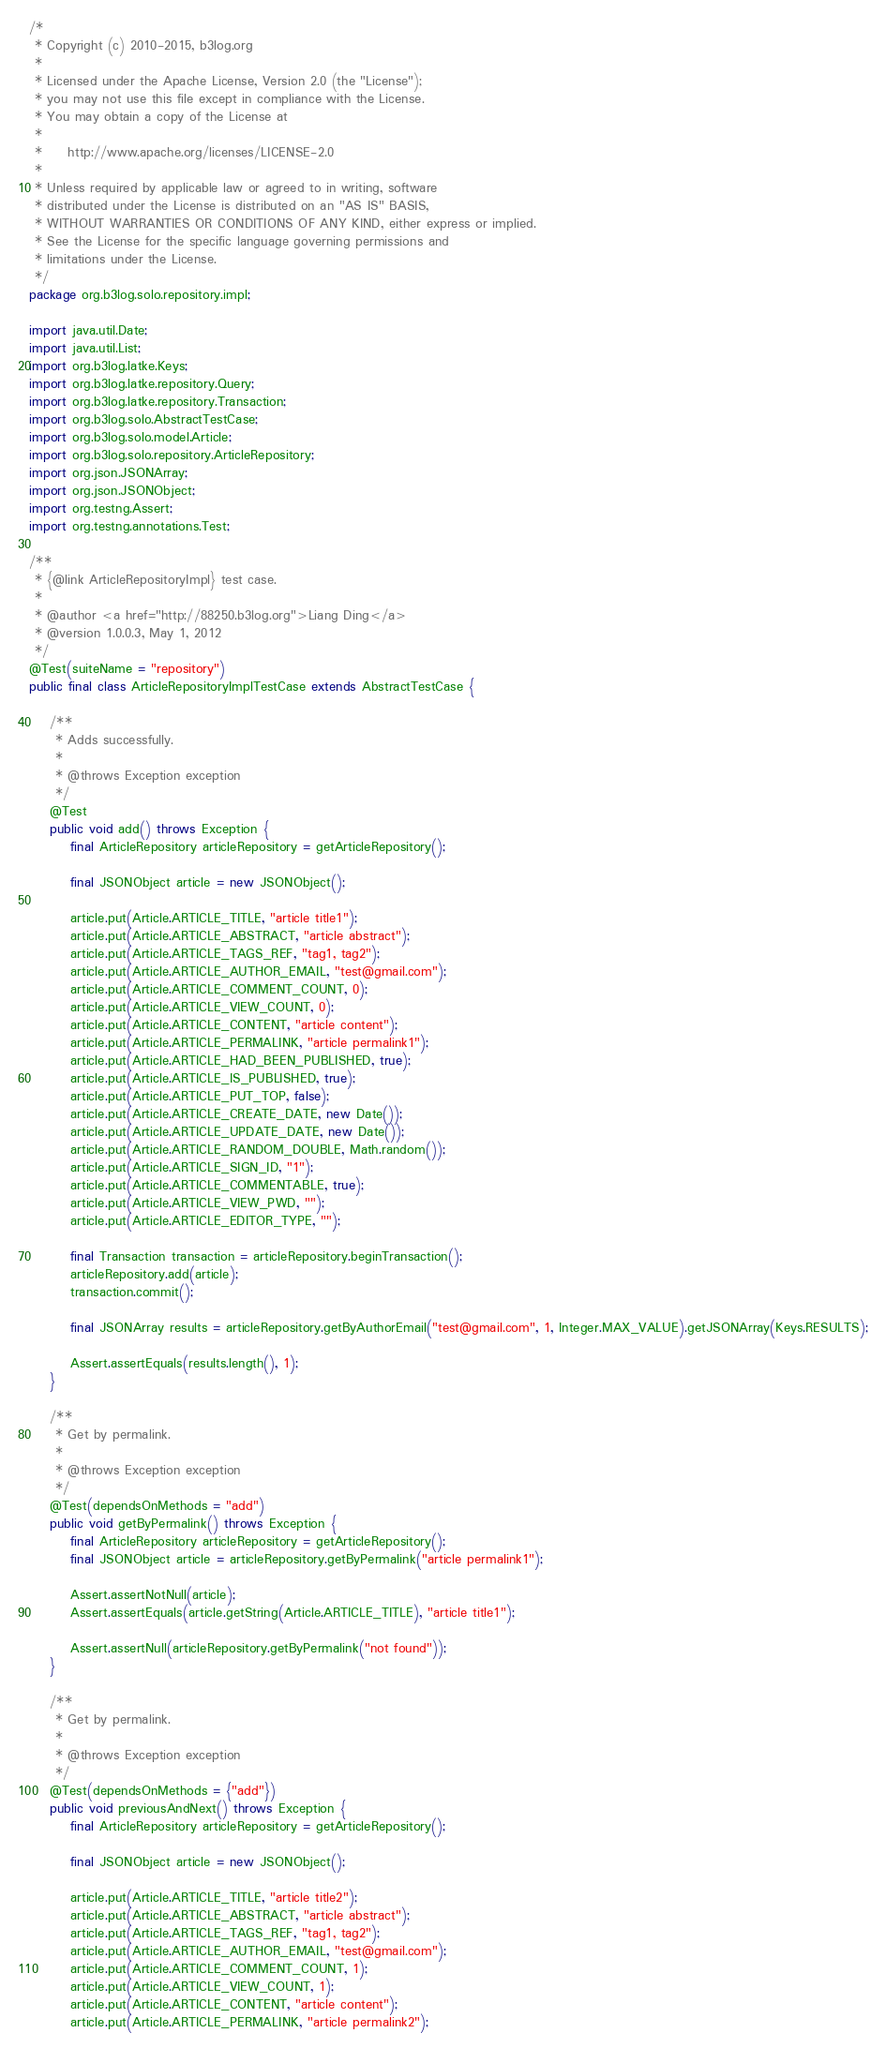Convert code to text. <code><loc_0><loc_0><loc_500><loc_500><_Java_>/*
 * Copyright (c) 2010-2015, b3log.org
 *
 * Licensed under the Apache License, Version 2.0 (the "License");
 * you may not use this file except in compliance with the License.
 * You may obtain a copy of the License at
 *
 *     http://www.apache.org/licenses/LICENSE-2.0
 *
 * Unless required by applicable law or agreed to in writing, software
 * distributed under the License is distributed on an "AS IS" BASIS,
 * WITHOUT WARRANTIES OR CONDITIONS OF ANY KIND, either express or implied.
 * See the License for the specific language governing permissions and
 * limitations under the License.
 */
package org.b3log.solo.repository.impl;

import java.util.Date;
import java.util.List;
import org.b3log.latke.Keys;
import org.b3log.latke.repository.Query;
import org.b3log.latke.repository.Transaction;
import org.b3log.solo.AbstractTestCase;
import org.b3log.solo.model.Article;
import org.b3log.solo.repository.ArticleRepository;
import org.json.JSONArray;
import org.json.JSONObject;
import org.testng.Assert;
import org.testng.annotations.Test;

/**
 * {@link ArticleRepositoryImpl} test case.
 *
 * @author <a href="http://88250.b3log.org">Liang Ding</a>
 * @version 1.0.0.3, May 1, 2012
 */
@Test(suiteName = "repository")
public final class ArticleRepositoryImplTestCase extends AbstractTestCase {

    /**
     * Adds successfully.
     * 
     * @throws Exception exception
     */
    @Test
    public void add() throws Exception {
        final ArticleRepository articleRepository = getArticleRepository();

        final JSONObject article = new JSONObject();

        article.put(Article.ARTICLE_TITLE, "article title1");
        article.put(Article.ARTICLE_ABSTRACT, "article abstract");
        article.put(Article.ARTICLE_TAGS_REF, "tag1, tag2");
        article.put(Article.ARTICLE_AUTHOR_EMAIL, "test@gmail.com");
        article.put(Article.ARTICLE_COMMENT_COUNT, 0);
        article.put(Article.ARTICLE_VIEW_COUNT, 0);
        article.put(Article.ARTICLE_CONTENT, "article content");
        article.put(Article.ARTICLE_PERMALINK, "article permalink1");
        article.put(Article.ARTICLE_HAD_BEEN_PUBLISHED, true);
        article.put(Article.ARTICLE_IS_PUBLISHED, true);
        article.put(Article.ARTICLE_PUT_TOP, false);
        article.put(Article.ARTICLE_CREATE_DATE, new Date());
        article.put(Article.ARTICLE_UPDATE_DATE, new Date());
        article.put(Article.ARTICLE_RANDOM_DOUBLE, Math.random());
        article.put(Article.ARTICLE_SIGN_ID, "1");
        article.put(Article.ARTICLE_COMMENTABLE, true);
        article.put(Article.ARTICLE_VIEW_PWD, "");
        article.put(Article.ARTICLE_EDITOR_TYPE, "");

        final Transaction transaction = articleRepository.beginTransaction();
        articleRepository.add(article);
        transaction.commit();

        final JSONArray results = articleRepository.getByAuthorEmail("test@gmail.com", 1, Integer.MAX_VALUE).getJSONArray(Keys.RESULTS);

        Assert.assertEquals(results.length(), 1);
    }

    /**
     * Get by permalink.
     * 
     * @throws Exception exception
     */
    @Test(dependsOnMethods = "add")
    public void getByPermalink() throws Exception {
        final ArticleRepository articleRepository = getArticleRepository();
        final JSONObject article = articleRepository.getByPermalink("article permalink1");

        Assert.assertNotNull(article);
        Assert.assertEquals(article.getString(Article.ARTICLE_TITLE), "article title1");

        Assert.assertNull(articleRepository.getByPermalink("not found"));
    }

    /**
     * Get by permalink.
     * 
     * @throws Exception exception
     */
    @Test(dependsOnMethods = {"add"})
    public void previousAndNext() throws Exception {
        final ArticleRepository articleRepository = getArticleRepository();

        final JSONObject article = new JSONObject();

        article.put(Article.ARTICLE_TITLE, "article title2");
        article.put(Article.ARTICLE_ABSTRACT, "article abstract");
        article.put(Article.ARTICLE_TAGS_REF, "tag1, tag2");
        article.put(Article.ARTICLE_AUTHOR_EMAIL, "test@gmail.com");
        article.put(Article.ARTICLE_COMMENT_COUNT, 1);
        article.put(Article.ARTICLE_VIEW_COUNT, 1);
        article.put(Article.ARTICLE_CONTENT, "article content");
        article.put(Article.ARTICLE_PERMALINK, "article permalink2");</code> 